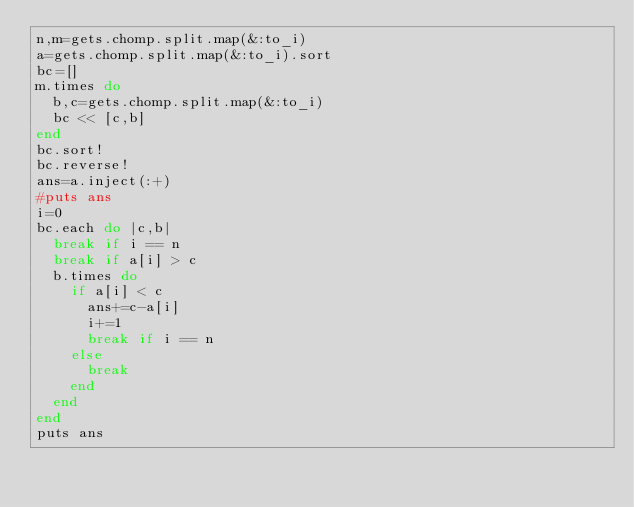Convert code to text. <code><loc_0><loc_0><loc_500><loc_500><_Ruby_>n,m=gets.chomp.split.map(&:to_i)
a=gets.chomp.split.map(&:to_i).sort
bc=[]
m.times do 
  b,c=gets.chomp.split.map(&:to_i)
  bc << [c,b]
end
bc.sort!
bc.reverse!
ans=a.inject(:+)
#puts ans
i=0
bc.each do |c,b|
  break if i == n
  break if a[i] > c
  b.times do
    if a[i] < c
      ans+=c-a[i]
      i+=1
      break if i == n
    else
      break
    end
  end
end
puts ans</code> 